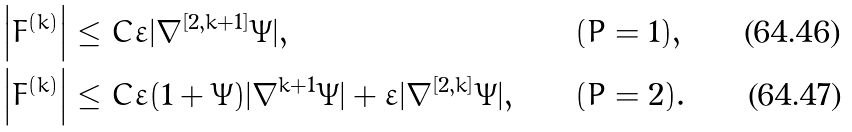Convert formula to latex. <formula><loc_0><loc_0><loc_500><loc_500>\left | F ^ { ( k ) } \right | & \leq C \varepsilon | \nabla ^ { [ 2 , k + 1 ] } \Psi | , & & ( P = 1 ) , \\ \left | F ^ { ( k ) } \right | & \leq C \varepsilon ( 1 + \Psi ) | \nabla ^ { k + 1 } \Psi | + \varepsilon | \nabla ^ { [ 2 , k ] } \Psi | , & & ( P = 2 ) .</formula> 